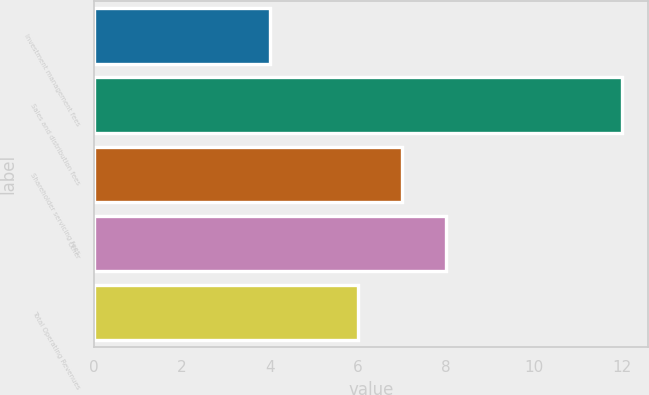<chart> <loc_0><loc_0><loc_500><loc_500><bar_chart><fcel>Investment management fees<fcel>Sales and distribution fees<fcel>Shareholder servicing fees<fcel>Other<fcel>Total Operating Revenues<nl><fcel>4<fcel>12<fcel>7<fcel>8<fcel>6<nl></chart> 